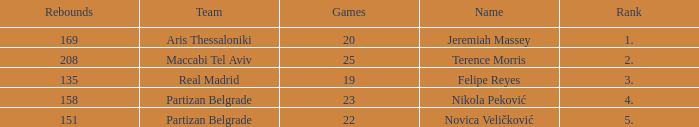What is the number of Games for the Maccabi Tel Aviv Team with less than 208 Rebounds? None. 